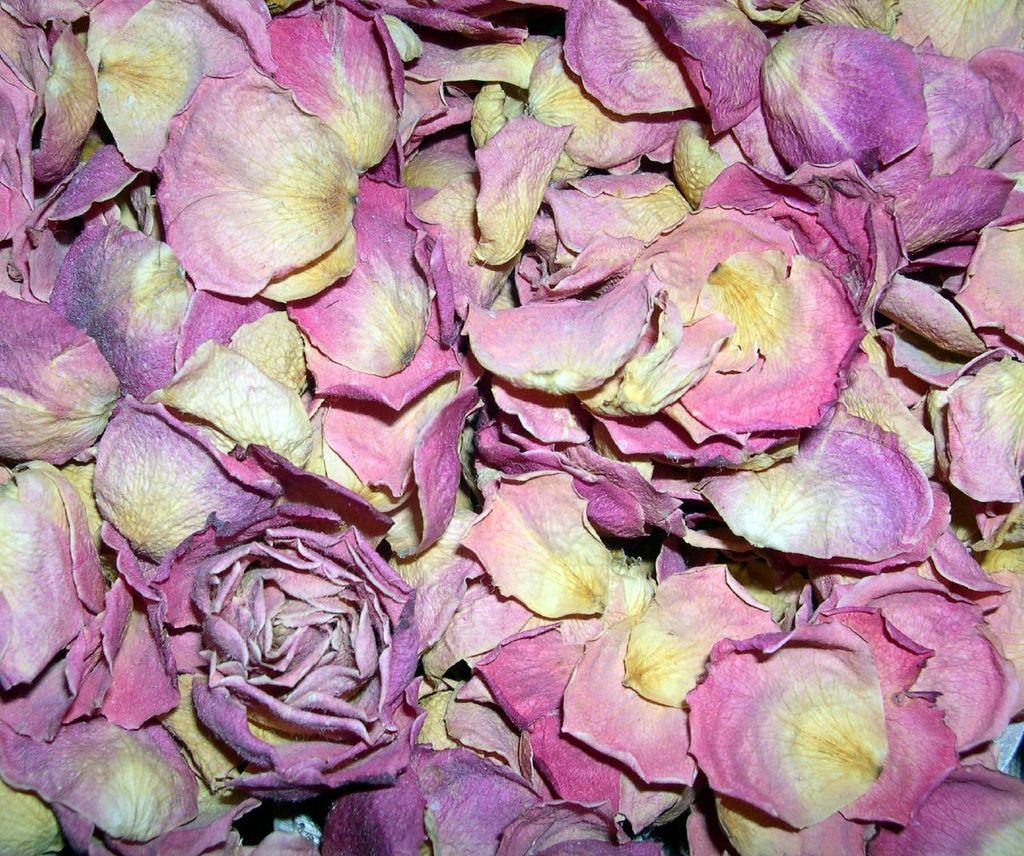What type of dried petals are in the image? There are dried rose petals in the image. Can you describe the color of the rose petals? The rose petals are pinkish in color. Where is the hat located in the image? There is no hat present in the image. What type of water body can be seen in the image? There is no harbor or any water body present in the image. Is it raining in the image? There is no indication of rain in the image. 